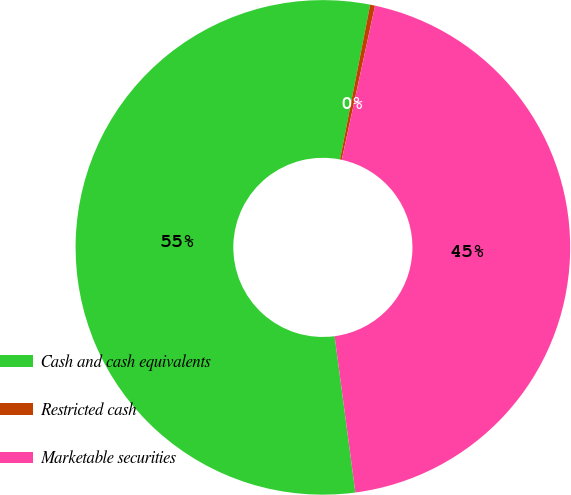<chart> <loc_0><loc_0><loc_500><loc_500><pie_chart><fcel>Cash and cash equivalents<fcel>Restricted cash<fcel>Marketable securities<nl><fcel>55.16%<fcel>0.32%<fcel>44.52%<nl></chart> 